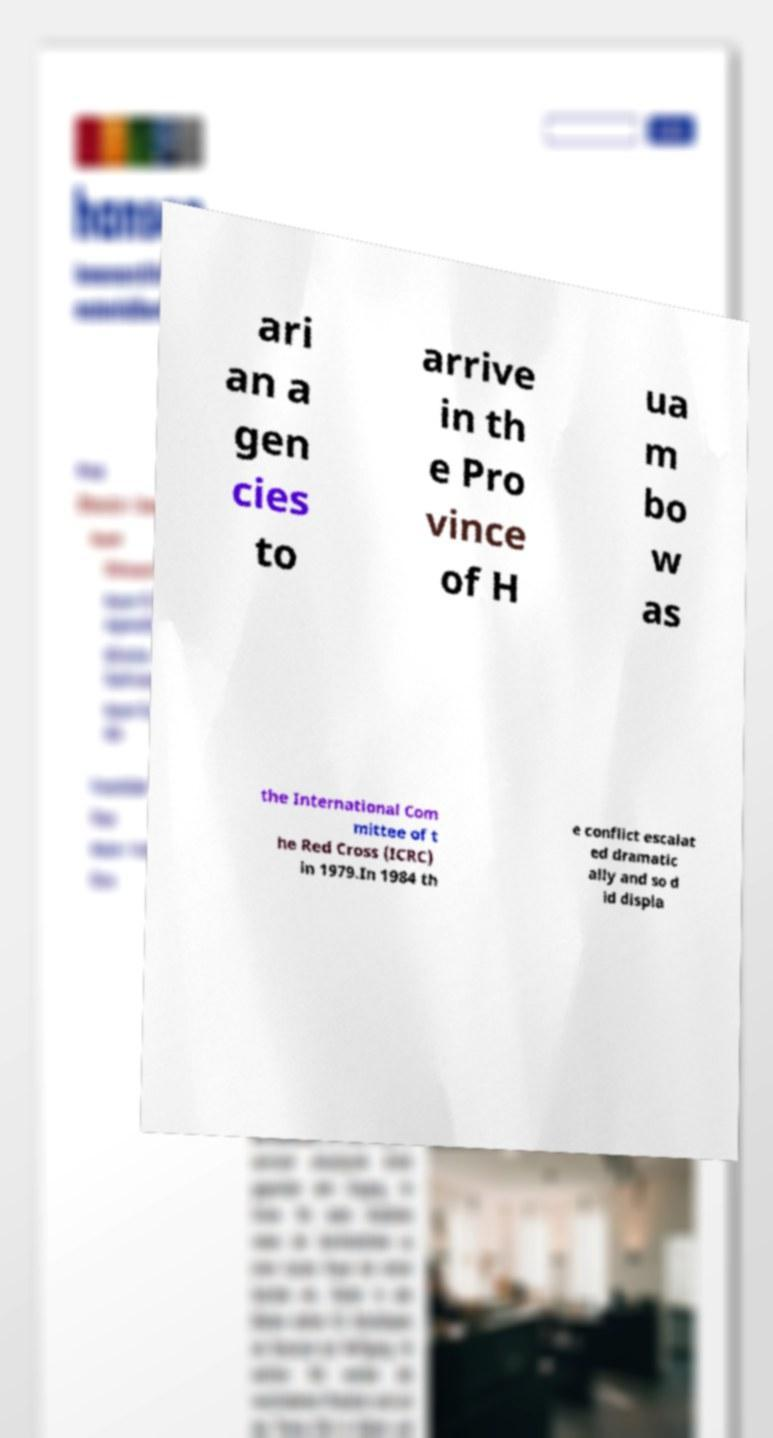For documentation purposes, I need the text within this image transcribed. Could you provide that? ari an a gen cies to arrive in th e Pro vince of H ua m bo w as the International Com mittee of t he Red Cross (ICRC) in 1979.In 1984 th e conflict escalat ed dramatic ally and so d id displa 